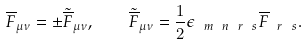<formula> <loc_0><loc_0><loc_500><loc_500>\overline { F } _ { \mu \nu } = \pm \tilde { \overline { F } } _ { \mu \nu } , \quad \tilde { \overline { F } } _ { \mu \nu } = \frac { 1 } { 2 } \epsilon _ { \ m \ n \ r \ s } \overline { F } _ { \ r \ s } .</formula> 